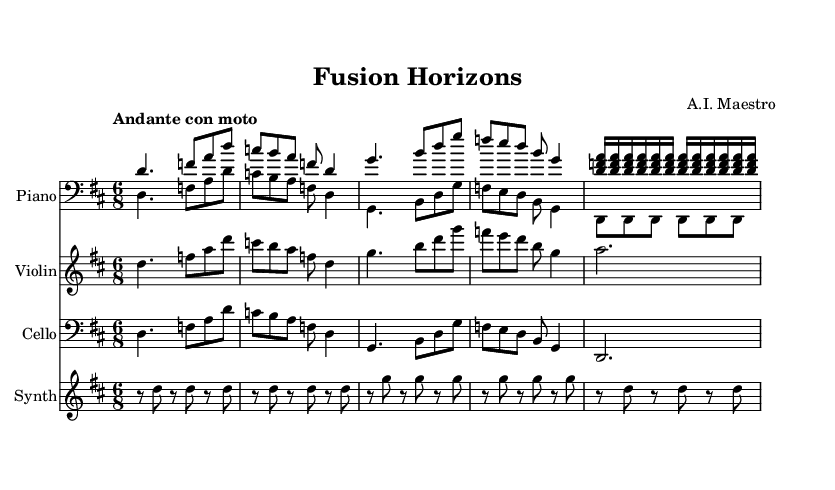What is the key signature of this piece? The key signature is D major, which has two sharps: F# and C#. This can be determined from the key indication at the beginning of the music.
Answer: D major What is the time signature of this music? The time signature is 6/8, indicated at the beginning of the score. This means there are six eighth notes per measure.
Answer: 6/8 What is the tempo marking for this composition? The tempo marking is "Andante con moto," which suggests a moderately slow but lively pace. This is found at the beginning of the sheet music.
Answer: Andante con moto Which instrument is playing the melody primarily? The violin is primarily playing the melody as it features prominently in the treble clef and has sustained notes. This can be observed as the violin line has more melodic content compared to the others.
Answer: Violin How many measures are repeated in the piano part? The piano part contains two measures that are explicitly indicated to repeat in the score with the "repeat unfold" command. This can be seen in the notation where the same arpeggiated chords appear twice.
Answer: 2 measures What type of chords are present in the piano part? The piano part features arpeggiated chords that are played in 16th notes. This means the notes of the chord are spread out and played sequentially rather than simultaneously, which is indicated by the notation layout and rhythm.
Answer: Arpeggiated chords Which instrument is indicated to have a synthesizer sound? The synthesizer sound is assigned to the "Synth" staff, where a pattern of repeated eighth notes can be seen, indicating an electronic or synthesized texture distinct from the acoustic instruments. This is clear in the separate staff labeled "Synth."
Answer: Synth 